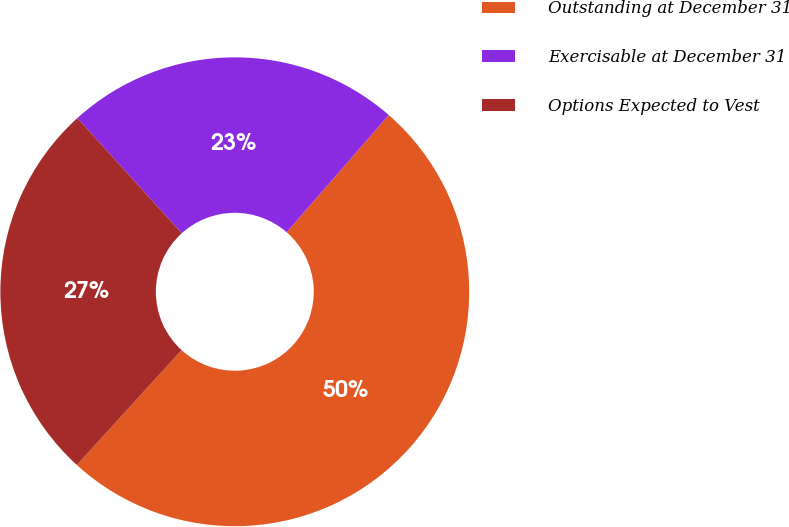Convert chart to OTSL. <chart><loc_0><loc_0><loc_500><loc_500><pie_chart><fcel>Outstanding at December 31<fcel>Exercisable at December 31<fcel>Options Expected to Vest<nl><fcel>50.36%<fcel>23.13%<fcel>26.51%<nl></chart> 